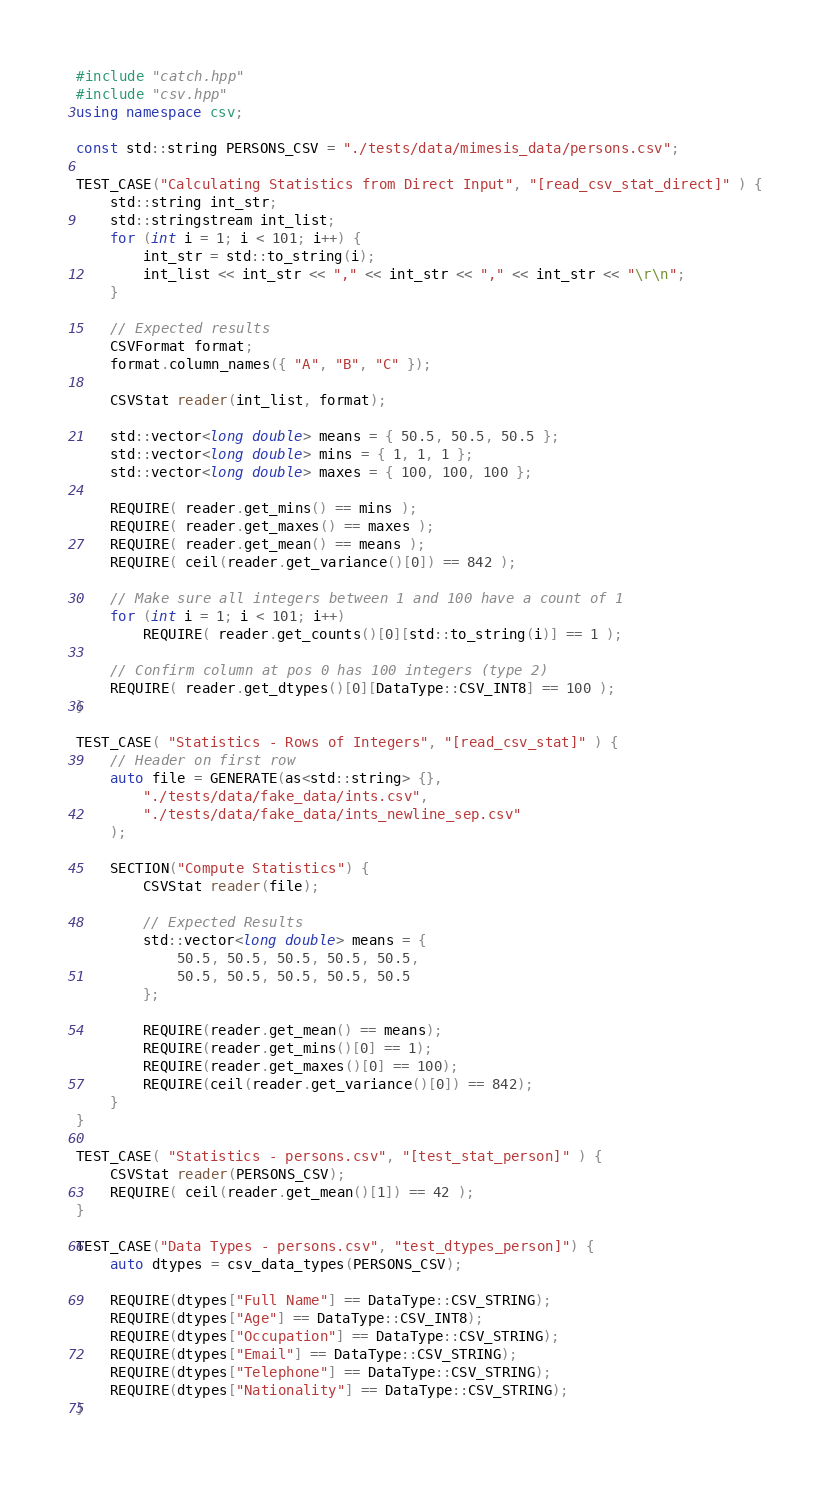<code> <loc_0><loc_0><loc_500><loc_500><_C++_>#include "catch.hpp"
#include "csv.hpp"
using namespace csv;

const std::string PERSONS_CSV = "./tests/data/mimesis_data/persons.csv";

TEST_CASE("Calculating Statistics from Direct Input", "[read_csv_stat_direct]" ) {
    std::string int_str;
    std::stringstream int_list;
    for (int i = 1; i < 101; i++) {
        int_str = std::to_string(i);
        int_list << int_str << "," << int_str << "," << int_str << "\r\n";
    }
    
    // Expected results
    CSVFormat format;
    format.column_names({ "A", "B", "C" });

    CSVStat reader(int_list, format);

    std::vector<long double> means = { 50.5, 50.5, 50.5 };
    std::vector<long double> mins = { 1, 1, 1 };
    std::vector<long double> maxes = { 100, 100, 100 };

    REQUIRE( reader.get_mins() == mins );
    REQUIRE( reader.get_maxes() == maxes );
    REQUIRE( reader.get_mean() == means );
    REQUIRE( ceil(reader.get_variance()[0]) == 842 );
    
    // Make sure all integers between 1 and 100 have a count of 1
    for (int i = 1; i < 101; i++)
        REQUIRE( reader.get_counts()[0][std::to_string(i)] == 1 );
    
    // Confirm column at pos 0 has 100 integers (type 2)
    REQUIRE( reader.get_dtypes()[0][DataType::CSV_INT8] == 100 );
}

TEST_CASE( "Statistics - Rows of Integers", "[read_csv_stat]" ) {
    // Header on first row
    auto file = GENERATE(as<std::string> {},
        "./tests/data/fake_data/ints.csv",
        "./tests/data/fake_data/ints_newline_sep.csv"
    );

    SECTION("Compute Statistics") {
        CSVStat reader(file);

        // Expected Results
        std::vector<long double> means = {
            50.5, 50.5, 50.5, 50.5, 50.5,
            50.5, 50.5, 50.5, 50.5, 50.5
        };

        REQUIRE(reader.get_mean() == means);
        REQUIRE(reader.get_mins()[0] == 1);
        REQUIRE(reader.get_maxes()[0] == 100);
        REQUIRE(ceil(reader.get_variance()[0]) == 842);
    }
}

TEST_CASE( "Statistics - persons.csv", "[test_stat_person]" ) {
    CSVStat reader(PERSONS_CSV);
    REQUIRE( ceil(reader.get_mean()[1]) == 42 );
}

TEST_CASE("Data Types - persons.csv", "test_dtypes_person]") {
    auto dtypes = csv_data_types(PERSONS_CSV);

    REQUIRE(dtypes["Full Name"] == DataType::CSV_STRING);
    REQUIRE(dtypes["Age"] == DataType::CSV_INT8);
    REQUIRE(dtypes["Occupation"] == DataType::CSV_STRING);
    REQUIRE(dtypes["Email"] == DataType::CSV_STRING);
    REQUIRE(dtypes["Telephone"] == DataType::CSV_STRING);
    REQUIRE(dtypes["Nationality"] == DataType::CSV_STRING);
}</code> 